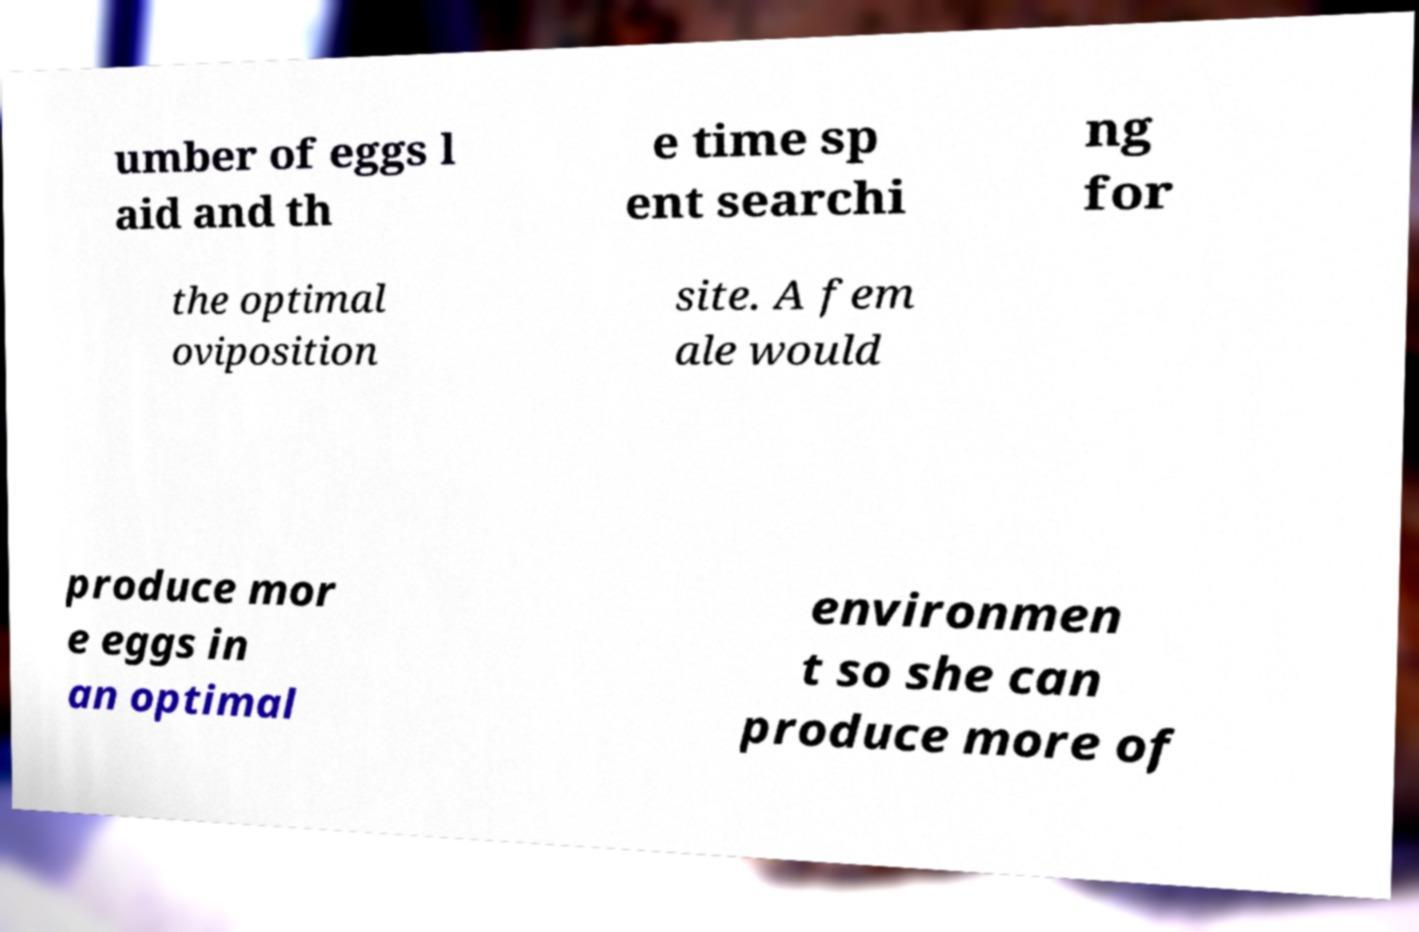For documentation purposes, I need the text within this image transcribed. Could you provide that? umber of eggs l aid and th e time sp ent searchi ng for the optimal oviposition site. A fem ale would produce mor e eggs in an optimal environmen t so she can produce more of 